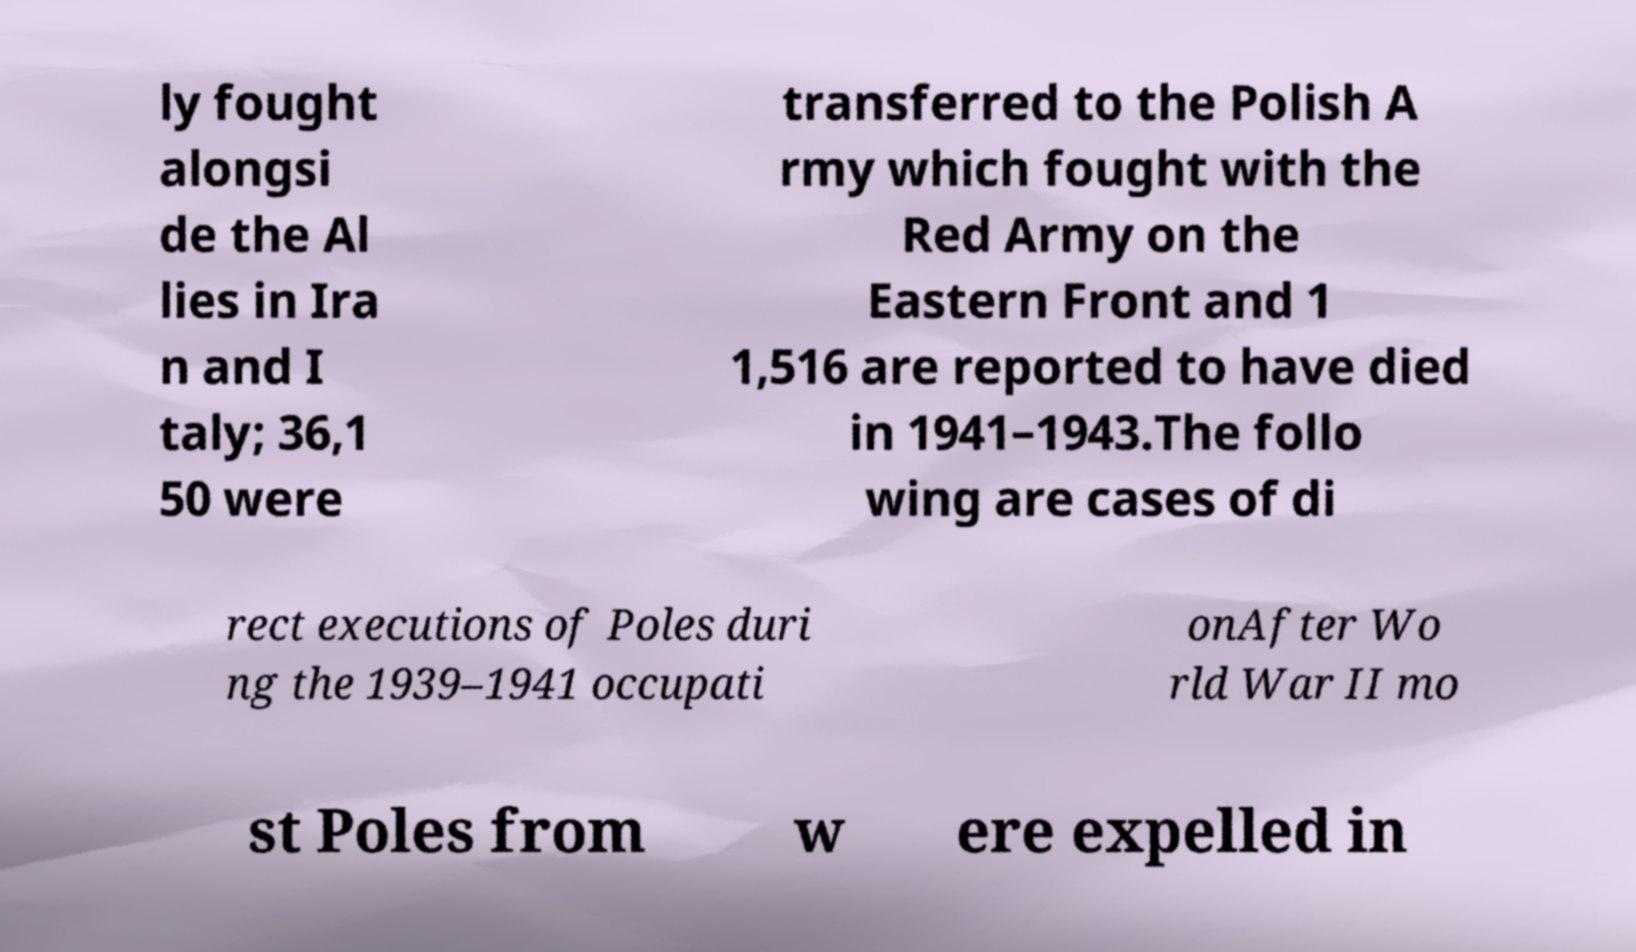Could you assist in decoding the text presented in this image and type it out clearly? ly fought alongsi de the Al lies in Ira n and I taly; 36,1 50 were transferred to the Polish A rmy which fought with the Red Army on the Eastern Front and 1 1,516 are reported to have died in 1941–1943.The follo wing are cases of di rect executions of Poles duri ng the 1939–1941 occupati onAfter Wo rld War II mo st Poles from w ere expelled in 